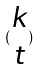<formula> <loc_0><loc_0><loc_500><loc_500>( \begin{matrix} k \\ t \end{matrix} )</formula> 